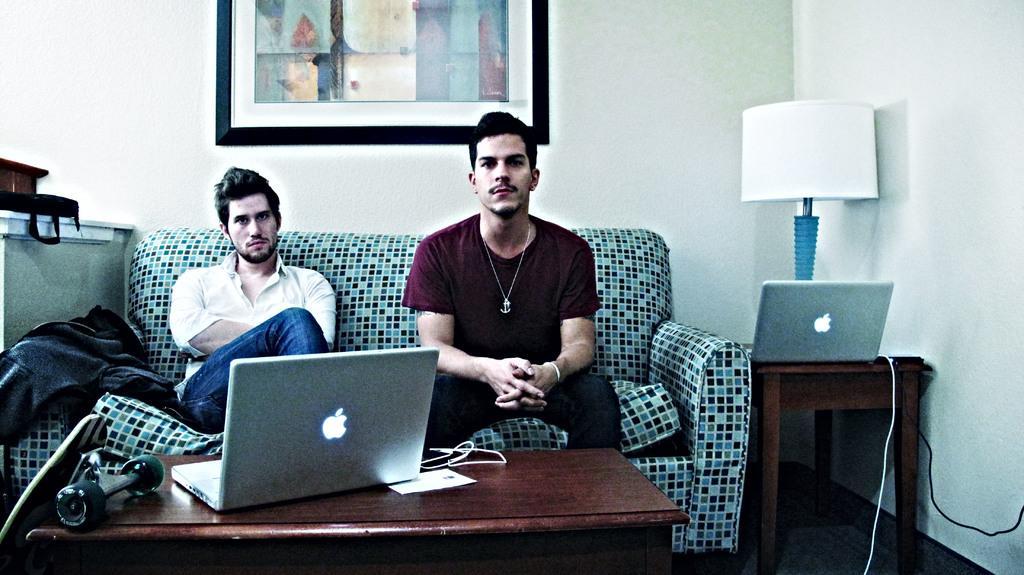Describe this image in one or two sentences. In this picture we can see two men sitting on sofa and in front of them on table we have laptop, dumbbell, paper, wires and beside to them we have lamp, laptop on other table and in background we can see wall with frame. 